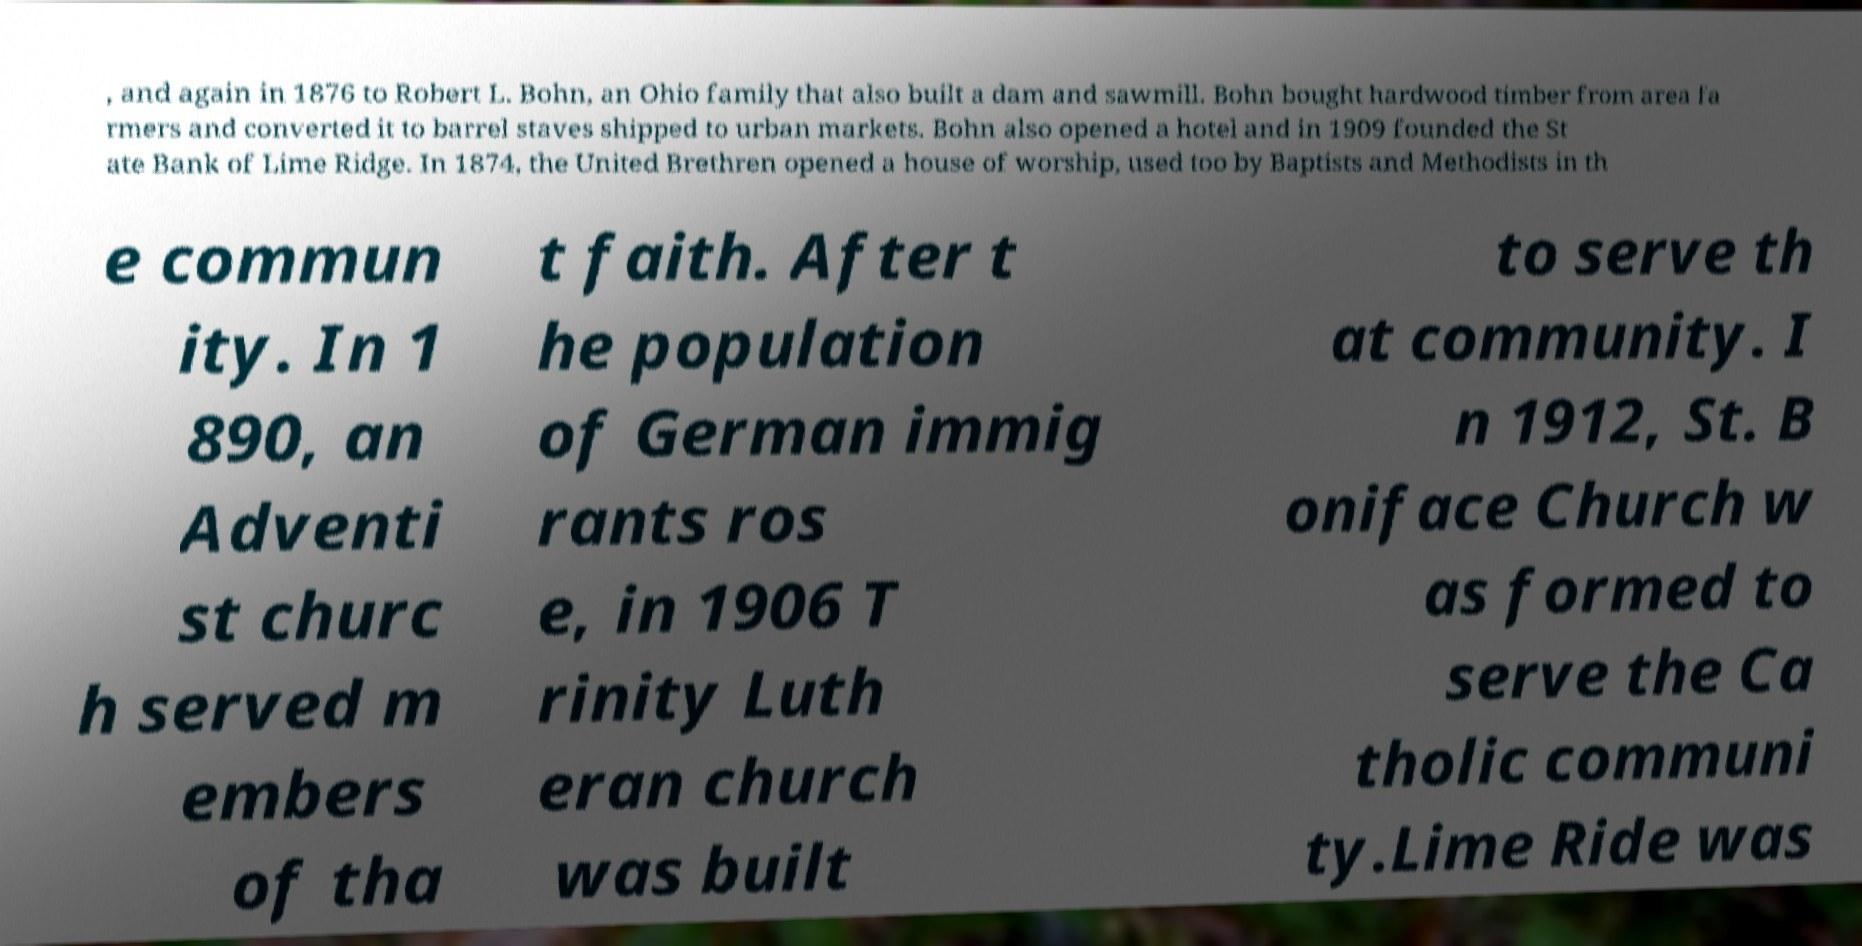Please identify and transcribe the text found in this image. , and again in 1876 to Robert L. Bohn, an Ohio family that also built a dam and sawmill. Bohn bought hardwood timber from area fa rmers and converted it to barrel staves shipped to urban markets. Bohn also opened a hotel and in 1909 founded the St ate Bank of Lime Ridge. In 1874, the United Brethren opened a house of worship, used too by Baptists and Methodists in th e commun ity. In 1 890, an Adventi st churc h served m embers of tha t faith. After t he population of German immig rants ros e, in 1906 T rinity Luth eran church was built to serve th at community. I n 1912, St. B oniface Church w as formed to serve the Ca tholic communi ty.Lime Ride was 